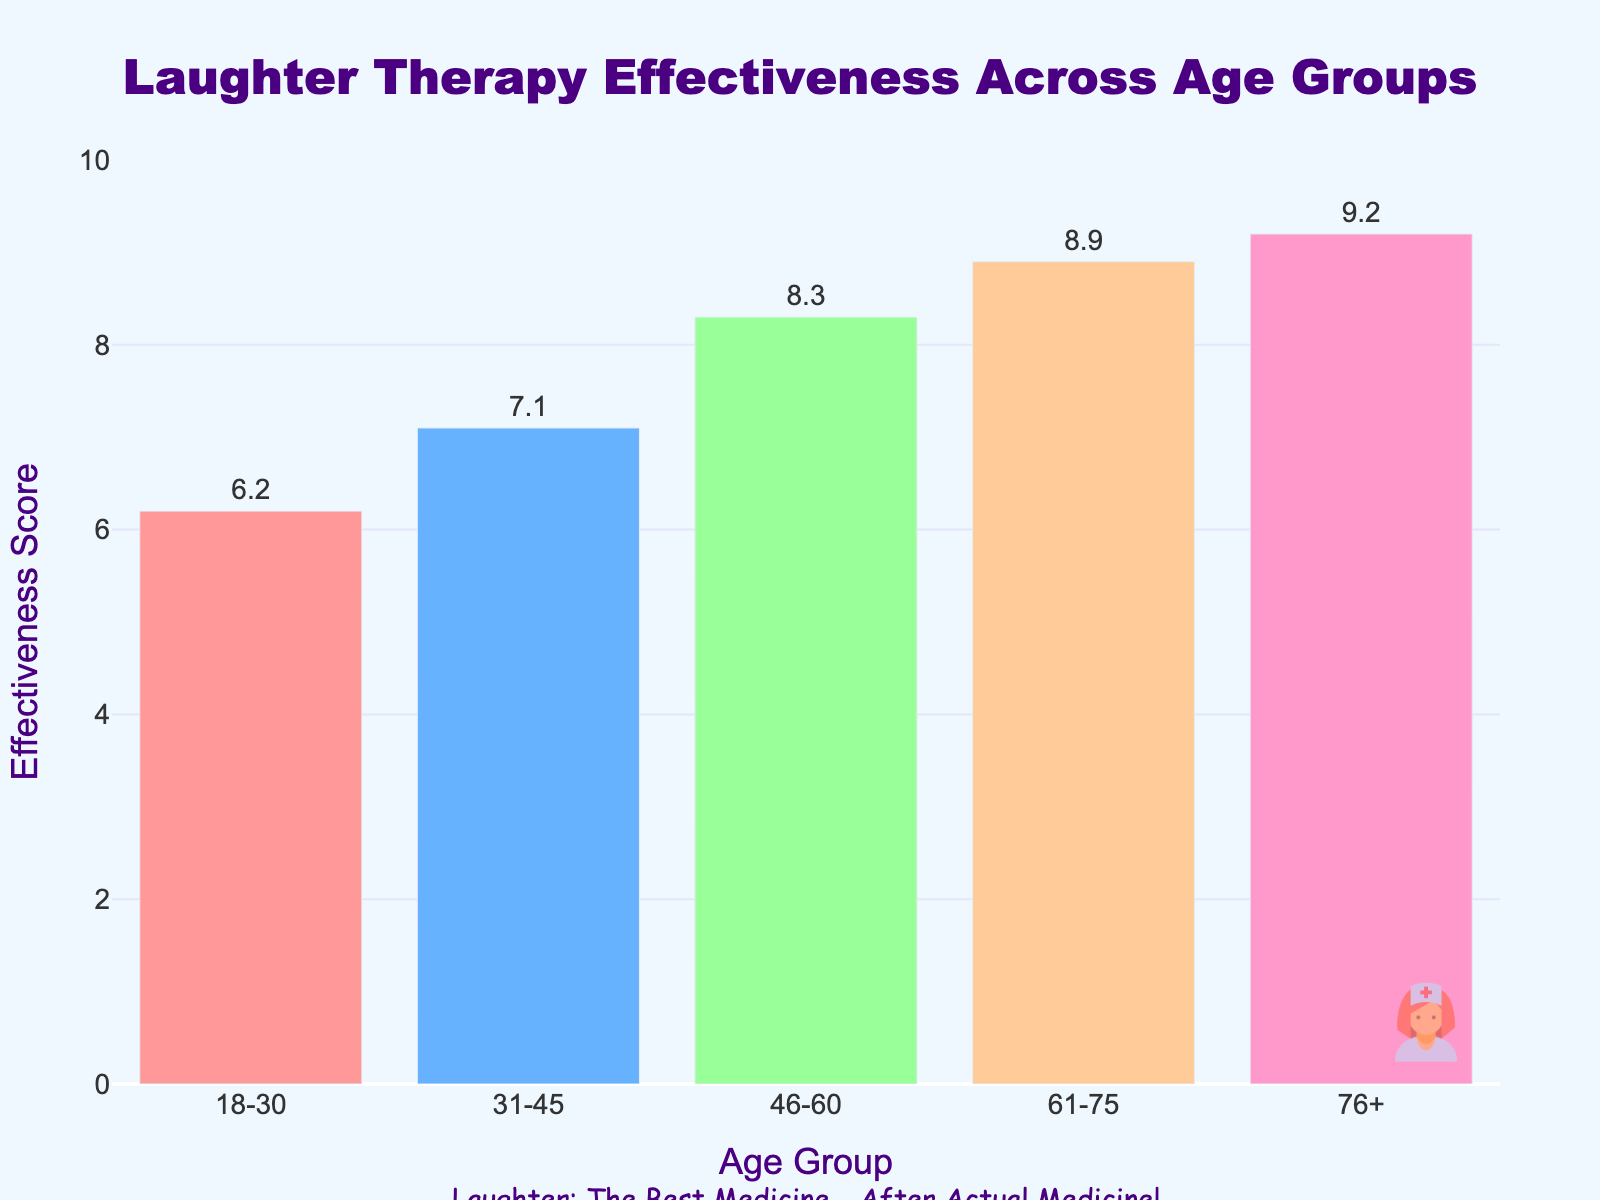Which age group has the highest effectiveness score? The "76+" age group has the highest effectiveness score of 9.2, as indicated by the tallest bar in the plot.
Answer: 76+ Which age group has the lowest effectiveness score? The "18-30" age group has the lowest effectiveness score of 6.2, as indicated by the shortest bar in the plot.
Answer: 18-30 What is the average effectiveness score across all age groups? Summing the scores (6.2 + 7.1 + 8.3 + 8.9 + 9.2) equals 39.7. Dividing by the number of groups (5) equals 7.94.
Answer: 7.94 Which two age groups have more than 8.5 effectiveness score? The age groups "61-75" and "76+" have effectiveness scores of 8.9 and 9.2 respectively, both more than 8.5.
Answer: 61-75, 76+ What is the difference in effectiveness score between the "18-30" and "76+" age groups? Subtracting the effectiveness score of "18-30" (6.2) from "76+" (9.2) gives a difference of 3.0.
Answer: 3.0 What is the sum of effectiveness scores for the age groups "46-60" and "61-75"? The effectiveness scores for "46-60" and "61-75" are 8.3 and 8.9 respectively. Summing them equals 17.2.
Answer: 17.2 Which age group has an effectiveness score closest to the average score? The average score is 7.94. The "31-45" age group has a score of 7.1, which is closest to the average.
Answer: 31-45 How many age groups have an effectiveness score higher than the overall average? The average score is 7.94. The age groups "46-60" (8.3), "61-75" (8.9), and "76+" (9.2) are higher than the average, so there are 3 such groups.
Answer: 3 Between which two consecutive age groups is the increase in effectiveness score the largest? The increase is largest between "31-45" (7.1) and "46-60" (8.3), which is an increase of 1.2.
Answer: 31-45, 46-60 What is the color of the bar representing the "31-45" age group? The bar for the "31-45" age group is colored blue.
Answer: Blue 